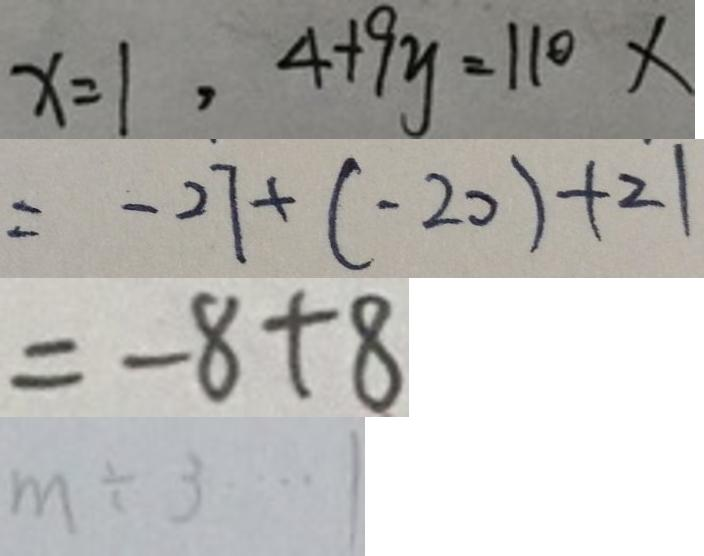<formula> <loc_0><loc_0><loc_500><loc_500>x = 1 , 4 + 9 y = 1 1 0 x 
 = - 2 7 + ( - 2 0 ) + 2 1 
 = - 8 + 8 
 m \div 3 \cdots 1</formula> 